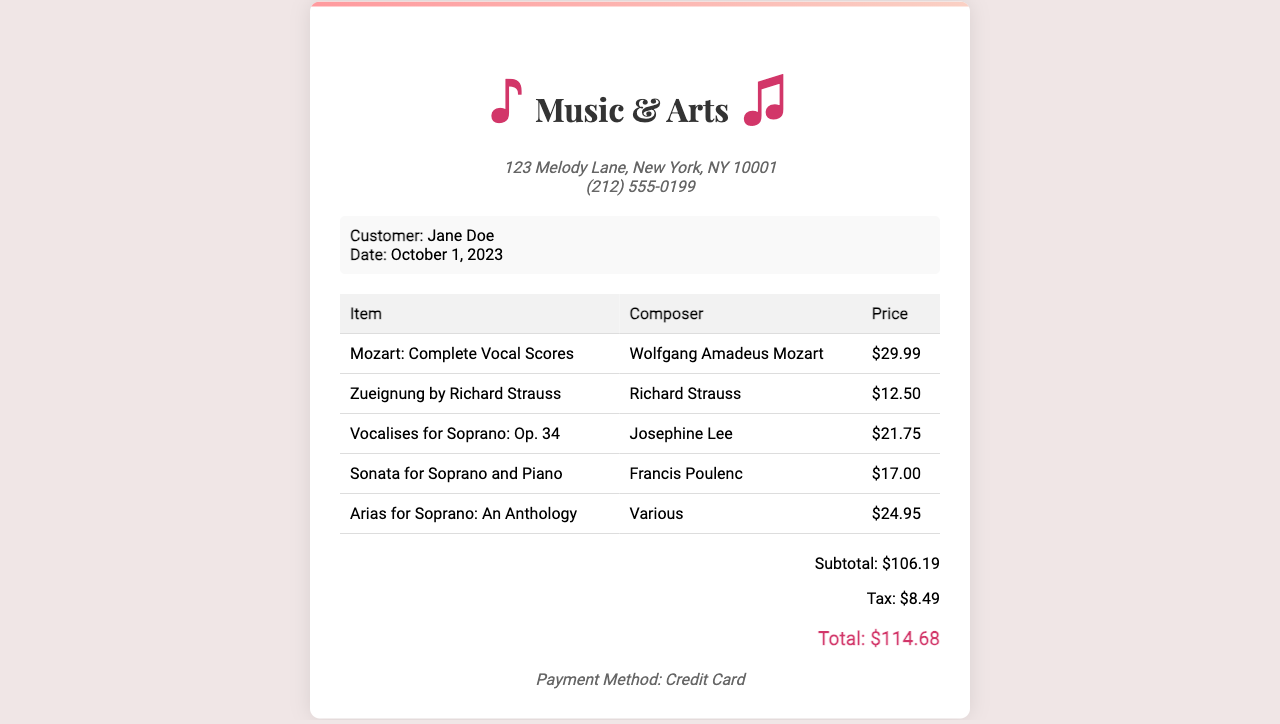What is the name of the store? The name of the store is stated at the top of the receipt, which is "Music & Arts."
Answer: Music & Arts Who is the customer? The customer's name is mentioned in the customer information section of the receipt.
Answer: Jane Doe What was the date of the purchase? The date of the purchase is specified in the customer information section.
Answer: October 1, 2023 What is the price of "Arias for Soprano: An Anthology"? The price of the item is listed in the table with the corresponding details of the purchase.
Answer: $24.95 How much was paid in tax? The tax amount is provided in the total section of the receipt.
Answer: $8.49 What is the subtotal of the purchase? The subtotal is outlined in the total section before tax and total amount.
Answer: $106.19 Which payment method was used? The payment method is stated at the bottom of the receipt, confirming how the customer paid.
Answer: Credit Card How many items were purchased in total? The total number of items can be counted from the rows in the items table.
Answer: 5 What is the total amount spent? The total amount spent is shown at the end of the receipt in the total section.
Answer: $114.68 